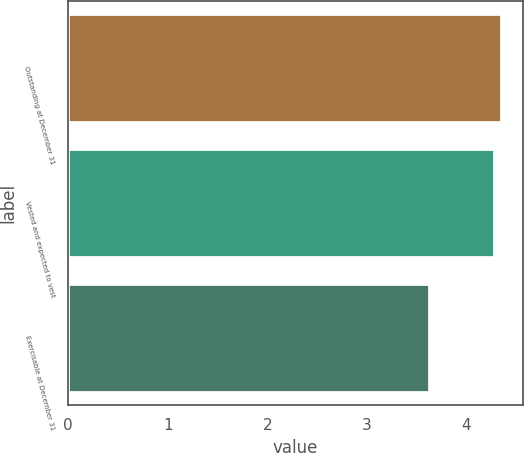<chart> <loc_0><loc_0><loc_500><loc_500><bar_chart><fcel>Outstanding at December 31<fcel>Vested and expected to vest<fcel>Exercisable at December 31<nl><fcel>4.35<fcel>4.28<fcel>3.62<nl></chart> 